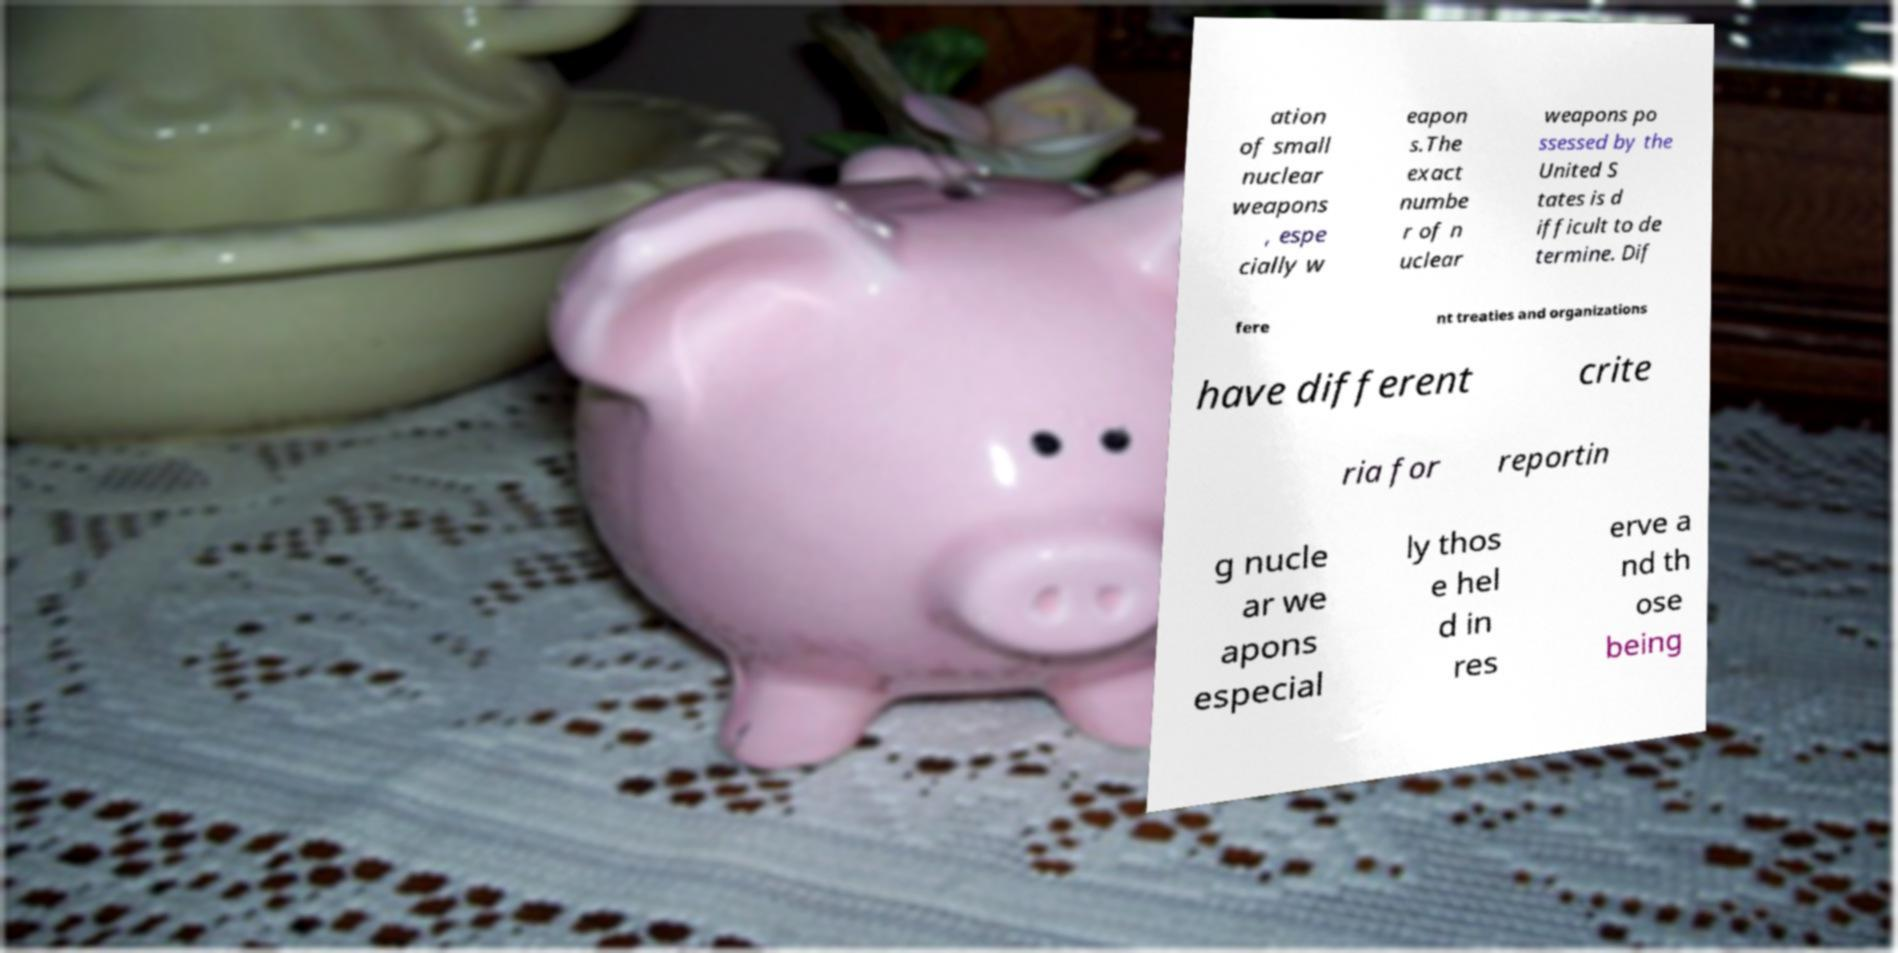Could you extract and type out the text from this image? ation of small nuclear weapons , espe cially w eapon s.The exact numbe r of n uclear weapons po ssessed by the United S tates is d ifficult to de termine. Dif fere nt treaties and organizations have different crite ria for reportin g nucle ar we apons especial ly thos e hel d in res erve a nd th ose being 